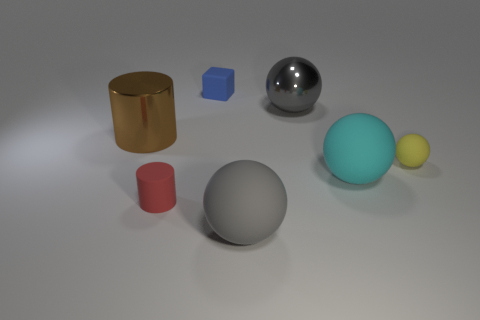The blue rubber thing that is the same size as the red thing is what shape?
Offer a very short reply. Cube. Do the matte cylinder and the large matte ball in front of the big cyan object have the same color?
Ensure brevity in your answer.  No. There is a metallic object that is to the left of the tiny blue rubber block; what number of blue cubes are in front of it?
Offer a terse response. 0. There is a rubber object that is both behind the red matte cylinder and left of the large gray metal ball; what is its size?
Ensure brevity in your answer.  Small. Are there any blue rubber objects that have the same size as the cyan sphere?
Make the answer very short. No. Is the number of tiny blue objects on the left side of the red cylinder greater than the number of large metallic cylinders that are on the left side of the large brown cylinder?
Offer a terse response. No. Is the material of the small block the same as the cylinder right of the big brown shiny thing?
Make the answer very short. Yes. There is a brown thing that is left of the rubber object that is behind the yellow thing; how many matte objects are in front of it?
Your answer should be compact. 4. Does the cyan object have the same shape as the metal object that is left of the matte cube?
Your response must be concise. No. The large object that is both behind the cyan ball and right of the large brown object is what color?
Make the answer very short. Gray. 